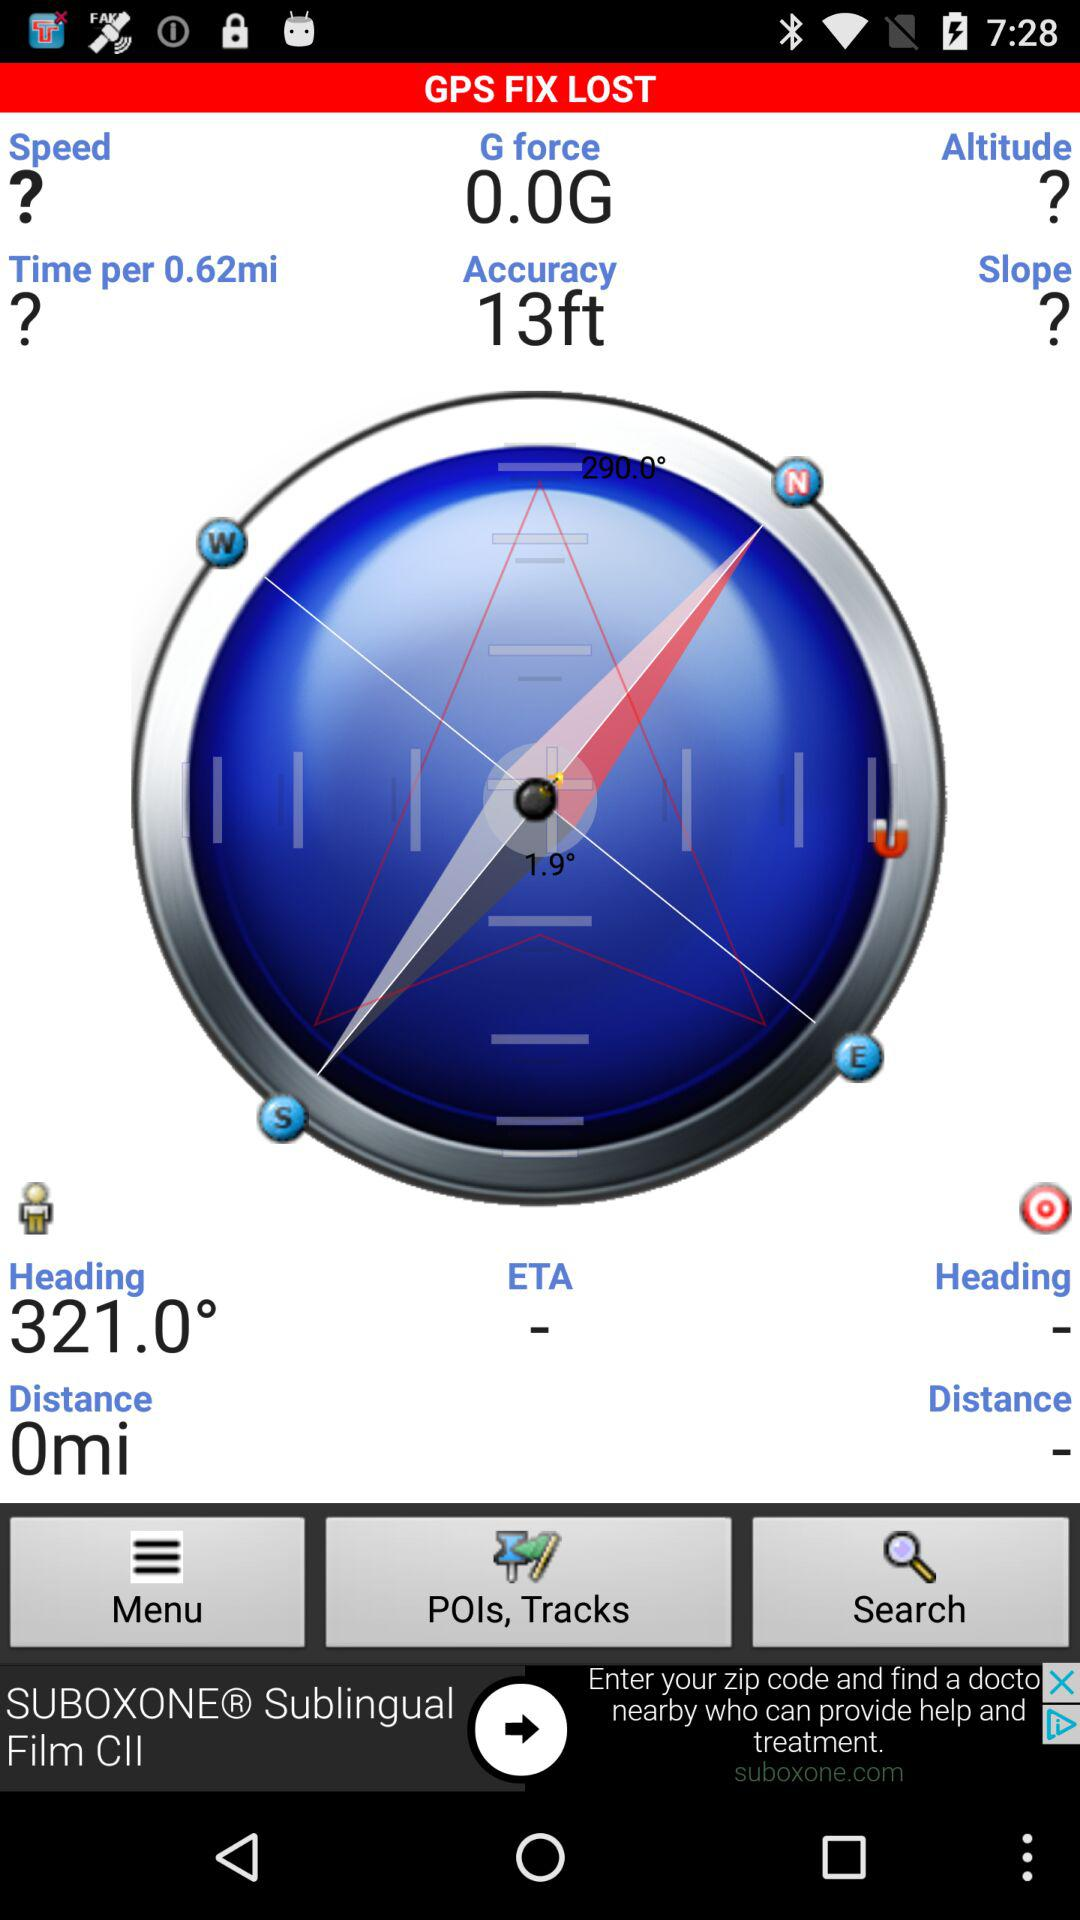What is "GPS FIX LOST" accuracy in feet? "GPS FIX LOST" accuracy in feet is 13. 